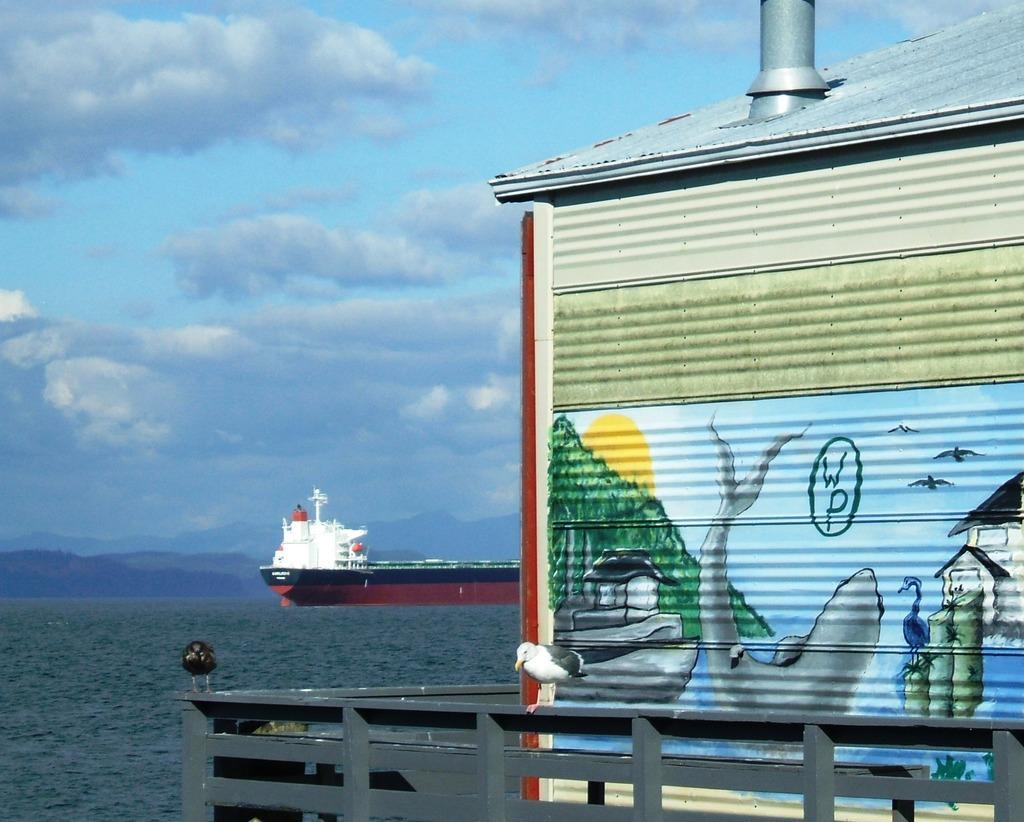In one or two sentences, can you explain what this image depicts? In this image there is a ship sailing on the surface of the water. Right side there is a house. Before it there is a fence. A bird is standing on the fence. On the wall of the house there is some picture painted on it. Background there are hills. Top of the image there is sky with some clouds. 